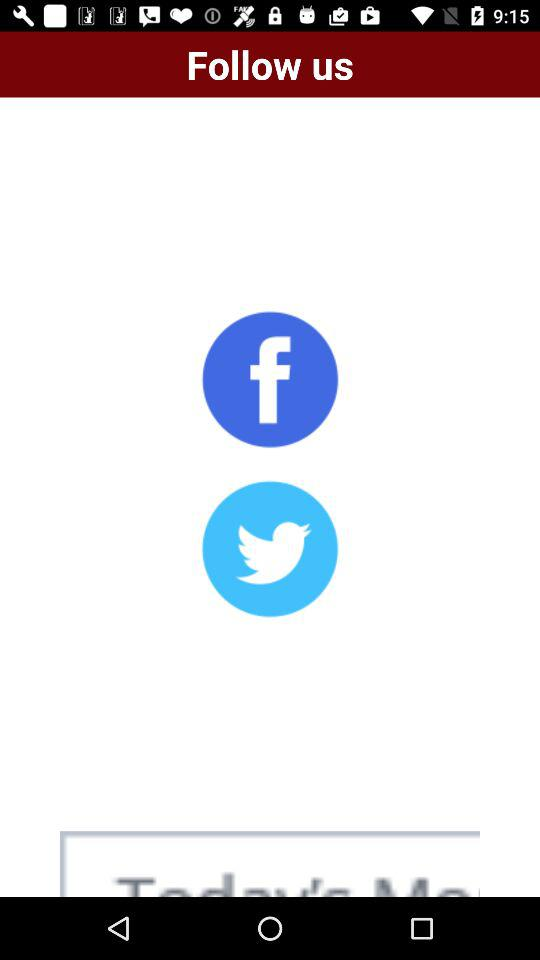What applications are used to follow? The applications used are "Facebook" and "Twitter". 